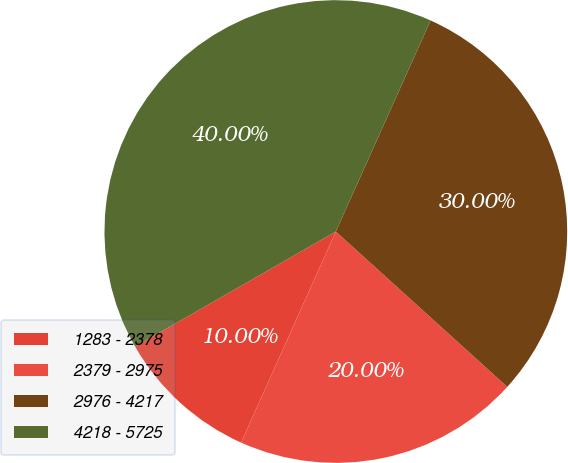Convert chart. <chart><loc_0><loc_0><loc_500><loc_500><pie_chart><fcel>1283 - 2378<fcel>2379 - 2975<fcel>2976 - 4217<fcel>4218 - 5725<nl><fcel>10.0%<fcel>20.0%<fcel>30.0%<fcel>40.0%<nl></chart> 